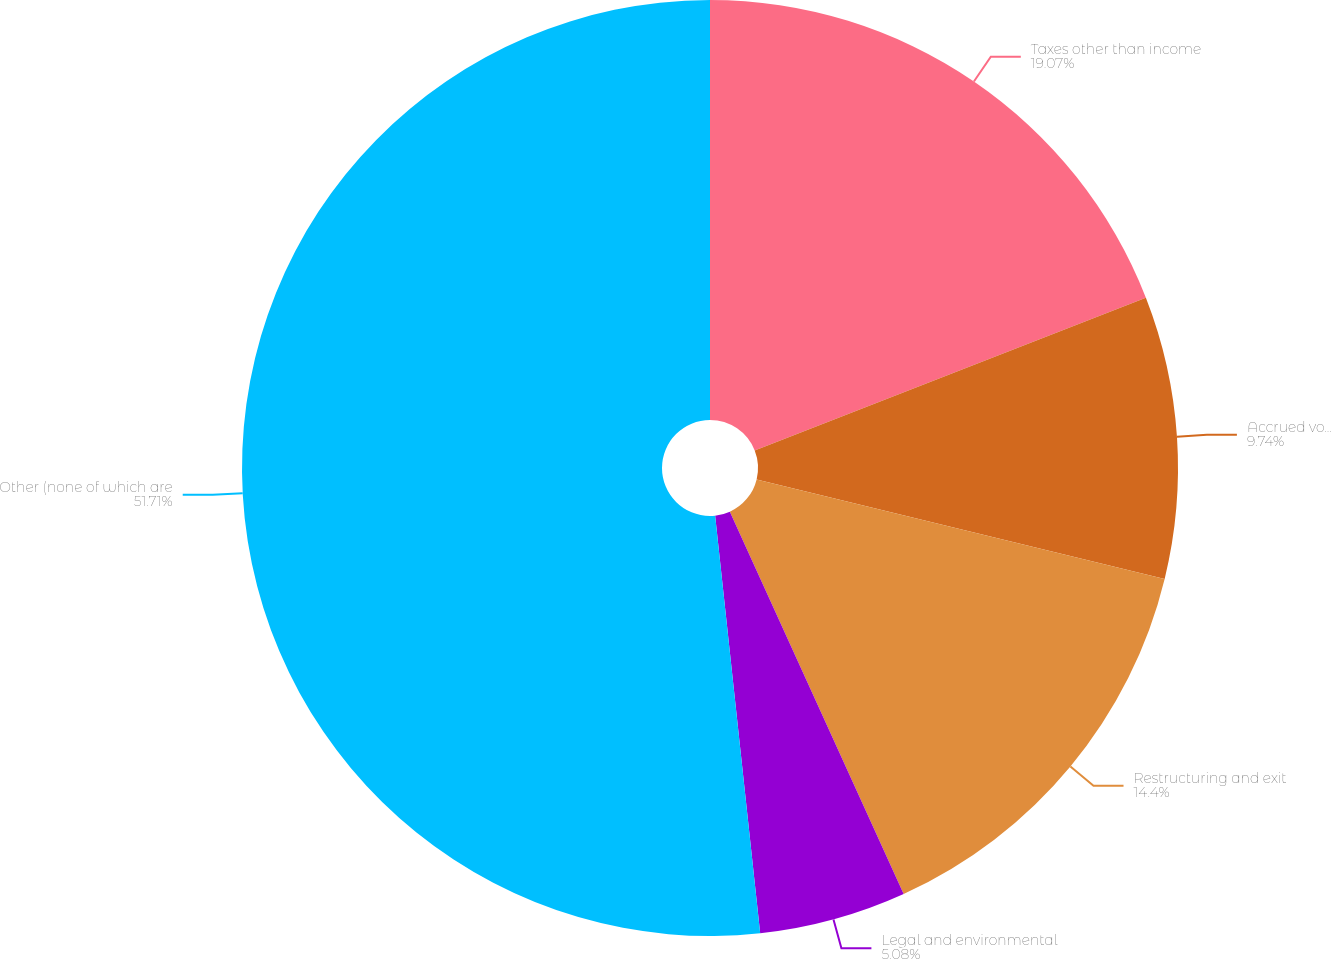<chart> <loc_0><loc_0><loc_500><loc_500><pie_chart><fcel>Taxes other than income<fcel>Accrued volume discounts<fcel>Restructuring and exit<fcel>Legal and environmental<fcel>Other (none of which are<nl><fcel>19.07%<fcel>9.74%<fcel>14.4%<fcel>5.08%<fcel>51.71%<nl></chart> 